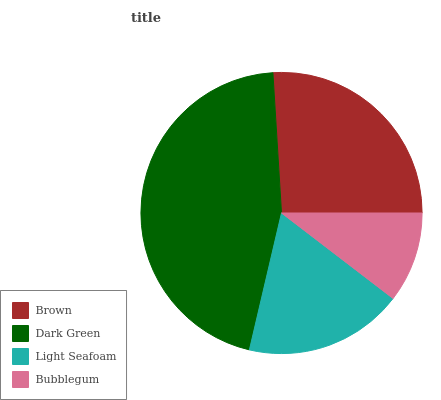Is Bubblegum the minimum?
Answer yes or no. Yes. Is Dark Green the maximum?
Answer yes or no. Yes. Is Light Seafoam the minimum?
Answer yes or no. No. Is Light Seafoam the maximum?
Answer yes or no. No. Is Dark Green greater than Light Seafoam?
Answer yes or no. Yes. Is Light Seafoam less than Dark Green?
Answer yes or no. Yes. Is Light Seafoam greater than Dark Green?
Answer yes or no. No. Is Dark Green less than Light Seafoam?
Answer yes or no. No. Is Brown the high median?
Answer yes or no. Yes. Is Light Seafoam the low median?
Answer yes or no. Yes. Is Dark Green the high median?
Answer yes or no. No. Is Dark Green the low median?
Answer yes or no. No. 